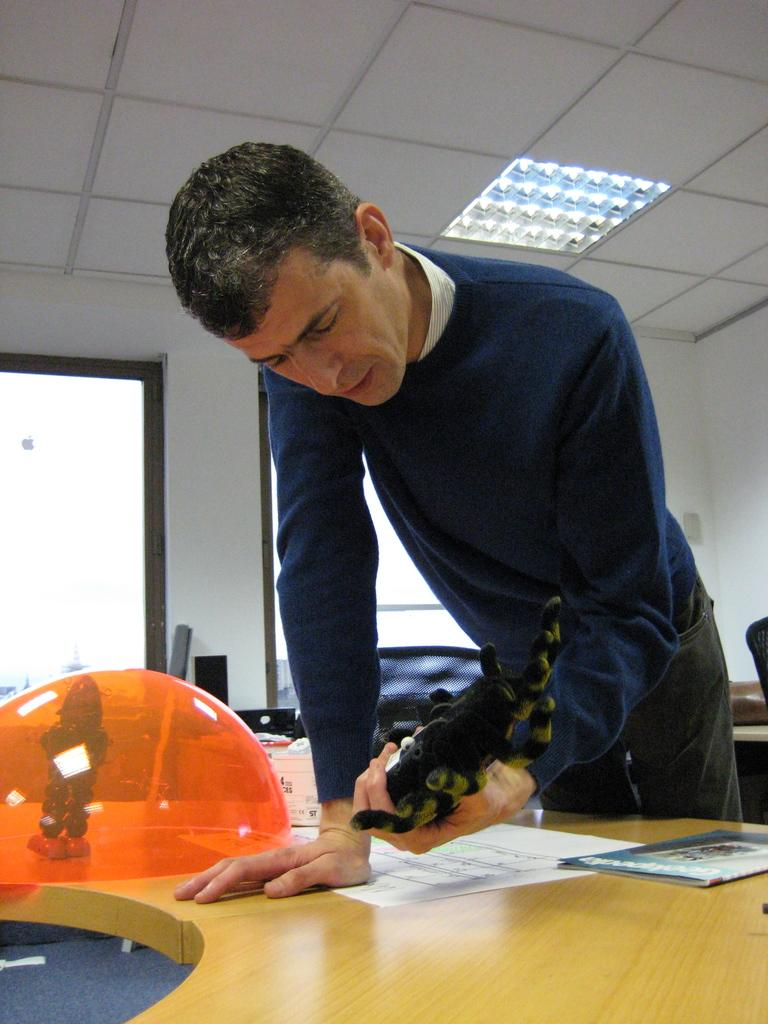What is the main subject in the image? There is a man standing in the image. What is on the table in the image? There are papers and a toy on the table. What can be seen through the windows in the image? The presence of windows suggests that there might be a view or outdoor scenery visible, but the specifics are not mentioned in the provided facts. How much juice is on the table in the image? There is no mention of juice in the provided facts, so it cannot be determined from the image. 